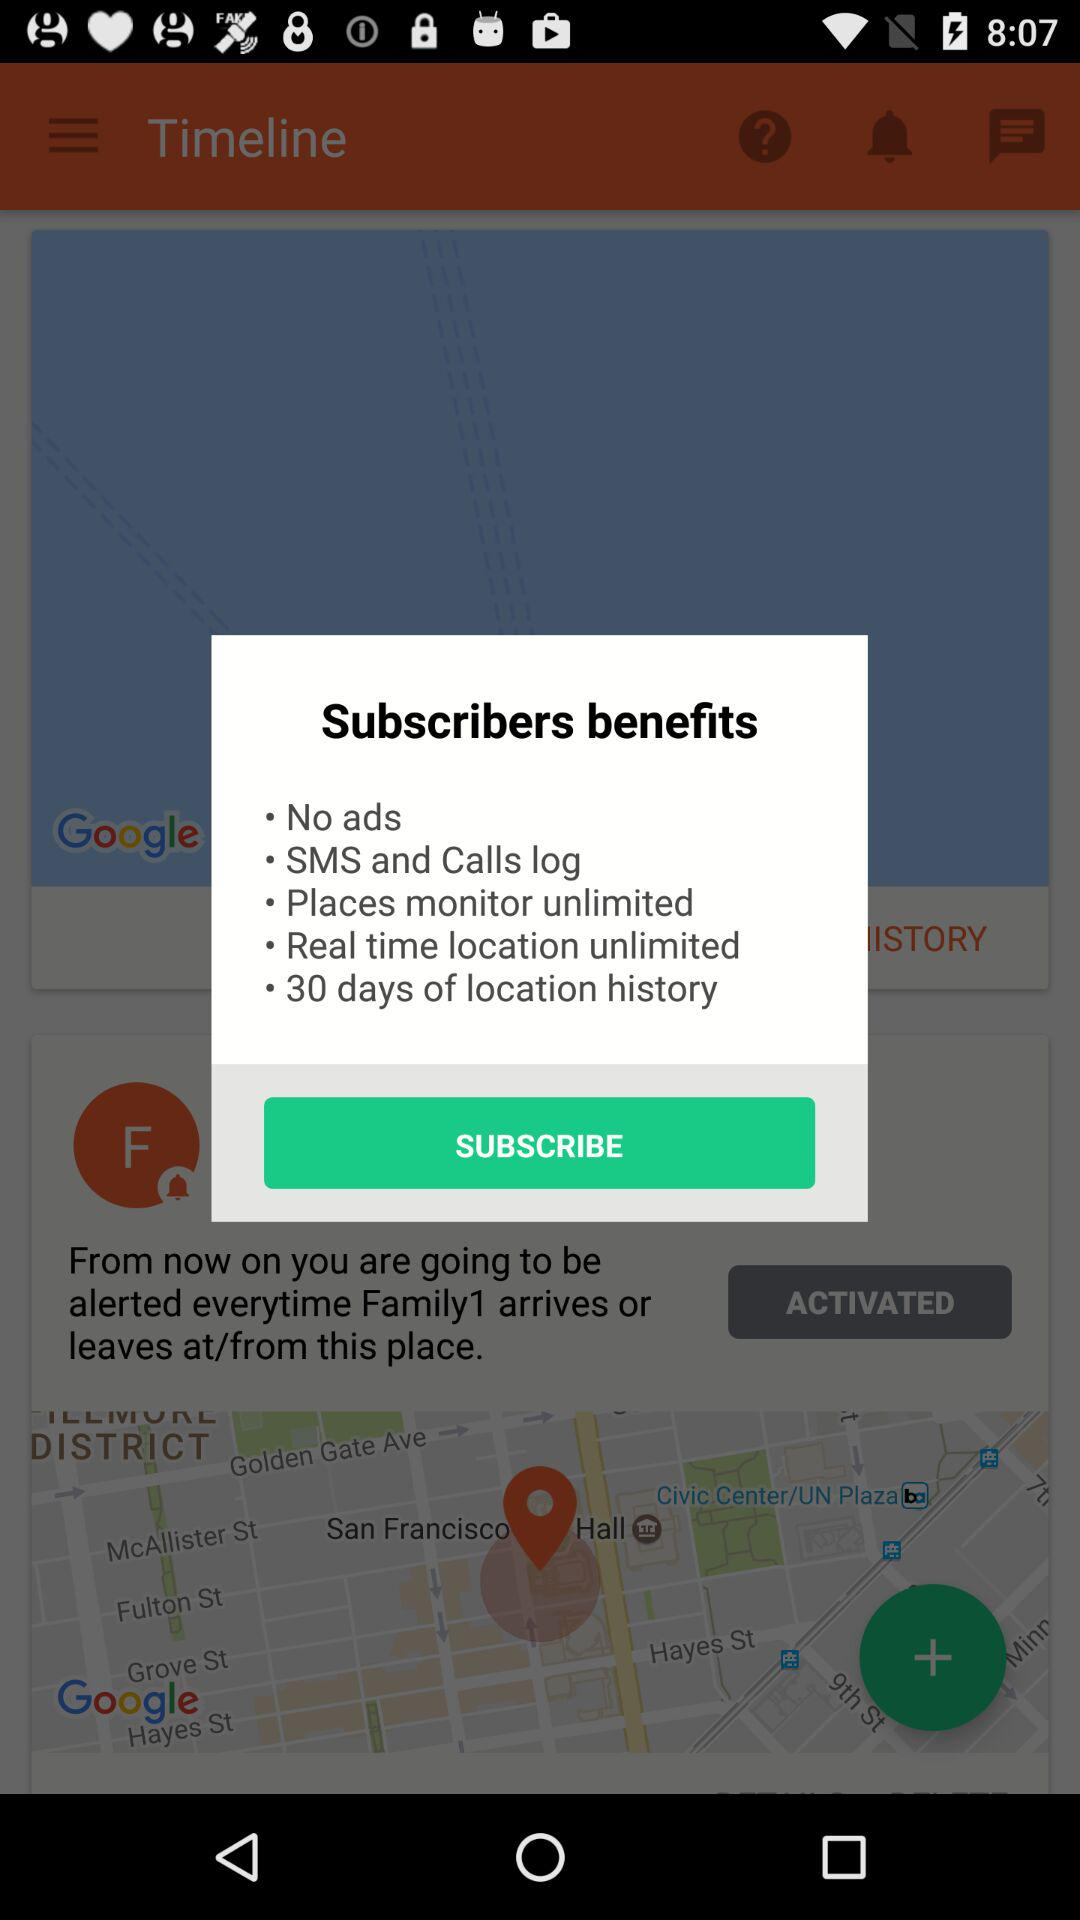How many days of location history are there? There are 30 days of location history. 